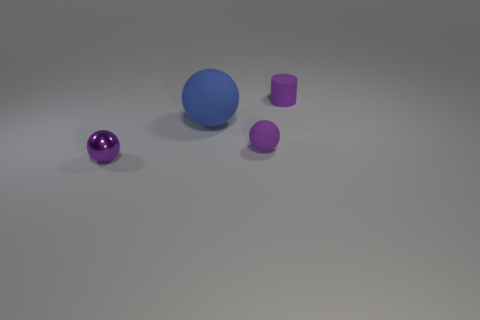How many other objects are the same size as the blue matte sphere?
Your response must be concise. 0. There is a small thing that is behind the blue ball that is on the left side of the small purple ball right of the big blue sphere; what is its material?
Ensure brevity in your answer.  Rubber. What number of cylinders are big blue matte things or purple shiny things?
Provide a succinct answer. 0. Are there more large spheres that are in front of the blue thing than purple objects on the left side of the tiny purple shiny thing?
Make the answer very short. No. What number of big blue rubber spheres are to the right of the rubber ball that is behind the purple matte ball?
Offer a terse response. 0. How many things are large blue spheres or tiny yellow matte spheres?
Keep it short and to the point. 1. Is the blue rubber thing the same shape as the metal object?
Your response must be concise. Yes. What material is the big blue sphere?
Make the answer very short. Rubber. How many spheres are both on the left side of the purple matte sphere and in front of the large blue rubber thing?
Your answer should be compact. 1. Does the purple matte sphere have the same size as the metallic ball?
Make the answer very short. Yes. 